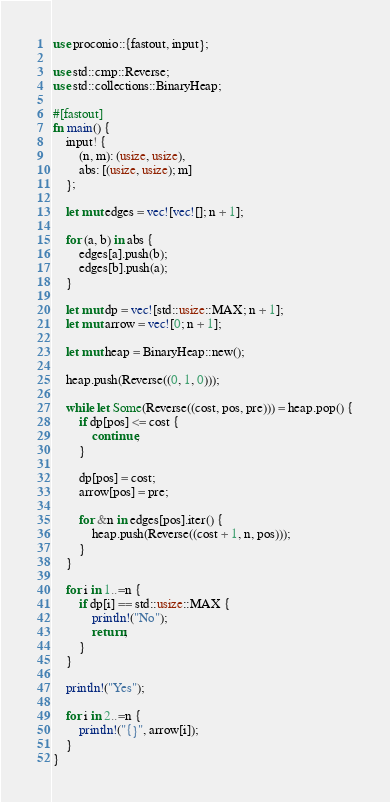<code> <loc_0><loc_0><loc_500><loc_500><_Rust_>use proconio::{fastout, input};

use std::cmp::Reverse;
use std::collections::BinaryHeap;

#[fastout]
fn main() {
    input! {
        (n, m): (usize, usize),
        abs: [(usize, usize); m]
    };

    let mut edges = vec![vec![]; n + 1];

    for (a, b) in abs {
        edges[a].push(b);
        edges[b].push(a);
    }

    let mut dp = vec![std::usize::MAX; n + 1];
    let mut arrow = vec![0; n + 1];

    let mut heap = BinaryHeap::new();

    heap.push(Reverse((0, 1, 0)));

    while let Some(Reverse((cost, pos, pre))) = heap.pop() {
        if dp[pos] <= cost {
            continue;
        }

        dp[pos] = cost;
        arrow[pos] = pre;

        for &n in edges[pos].iter() {
            heap.push(Reverse((cost + 1, n, pos)));
        }
    }

    for i in 1..=n {
        if dp[i] == std::usize::MAX {
            println!("No");
            return;
        }
    }

    println!("Yes");

    for i in 2..=n {
        println!("{}", arrow[i]);
    }
}
</code> 